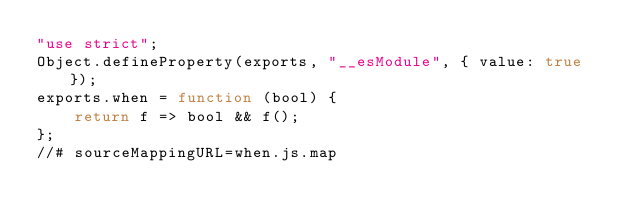Convert code to text. <code><loc_0><loc_0><loc_500><loc_500><_JavaScript_>"use strict";
Object.defineProperty(exports, "__esModule", { value: true });
exports.when = function (bool) {
    return f => bool && f();
};
//# sourceMappingURL=when.js.map</code> 